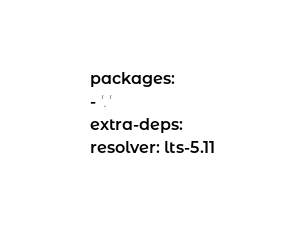Convert code to text. <code><loc_0><loc_0><loc_500><loc_500><_YAML_>packages:
- '.'
extra-deps:
resolver: lts-5.11
</code> 